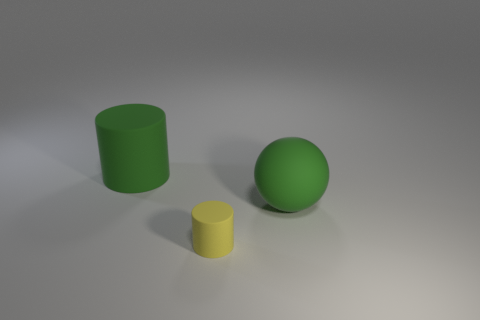There is a thing behind the green sphere; does it have the same color as the big ball that is behind the yellow rubber cylinder?
Offer a very short reply. Yes. There is a matte object that is the same color as the ball; what size is it?
Ensure brevity in your answer.  Large. Does the big rubber object that is right of the yellow rubber thing have the same color as the big matte cylinder?
Give a very brief answer. Yes. There is a matte ball that is behind the rubber cylinder that is in front of the matte sphere; is there a rubber cylinder that is in front of it?
Make the answer very short. Yes. What is the material of the big thing in front of the big green cylinder?
Provide a succinct answer. Rubber. What number of small objects are either green blocks or rubber spheres?
Give a very brief answer. 0. Is the size of the green matte object that is to the right of the green matte cylinder the same as the large green rubber cylinder?
Your response must be concise. Yes. What number of other objects are there of the same color as the small matte thing?
Your response must be concise. 0. What material is the yellow thing?
Give a very brief answer. Rubber. How many objects are either big rubber things in front of the large rubber cylinder or yellow objects?
Provide a succinct answer. 2. 